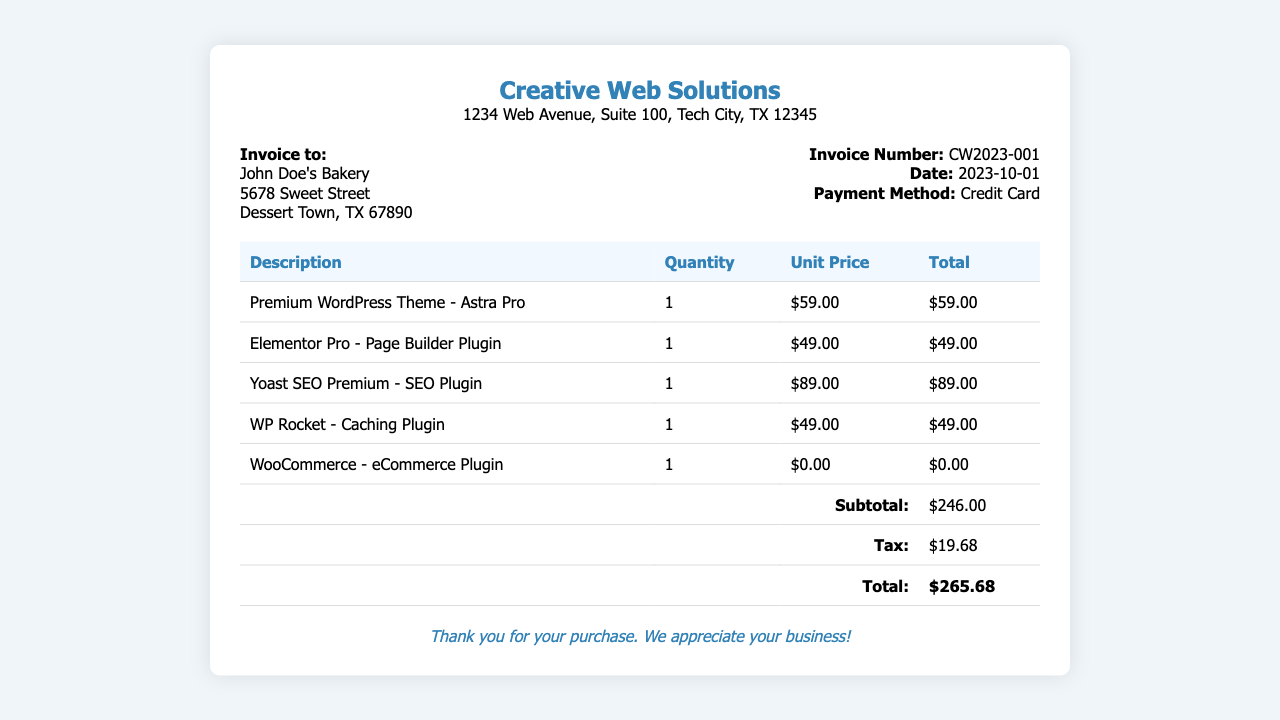What is the invoice number? The invoice number is a unique identifier for the purchase, listed in the document.
Answer: CW2023-001 What date was the invoice issued? The date of the invoice is provided in the document under the invoice details section.
Answer: 2023-10-01 Who is the invoice addressed to? The recipient of the invoice is specified at the top under the "Invoice to" section.
Answer: John Doe's Bakery What is the total amount due? The total amount due is indicated at the bottom of the table, summing up all charges.
Answer: $265.68 How much tax was charged? The tax amount is listed separately in the table, providing clarity on the additional cost.
Answer: $19.68 What is the unit price of Elementor Pro? The unit price is shown in the table under the "Unit Price" column next to Elementor Pro.
Answer: $49.00 Which payment method was used? The payment method is mentioned in the invoice details section of the document.
Answer: Credit Card How many different plugins are listed on the receipt? The number of plugins can be determined by counting the entries in the table.
Answer: 5 What is the subtotal amount before tax? The subtotal is provided in the table before tax is added.
Answer: $246.00 